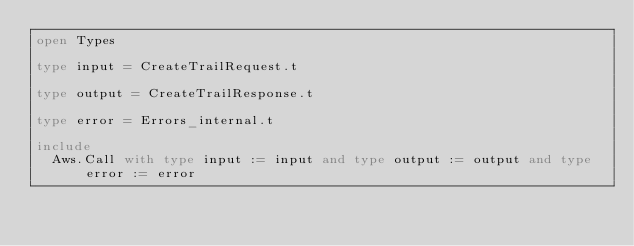<code> <loc_0><loc_0><loc_500><loc_500><_OCaml_>open Types

type input = CreateTrailRequest.t

type output = CreateTrailResponse.t

type error = Errors_internal.t

include
  Aws.Call with type input := input and type output := output and type error := error
</code> 